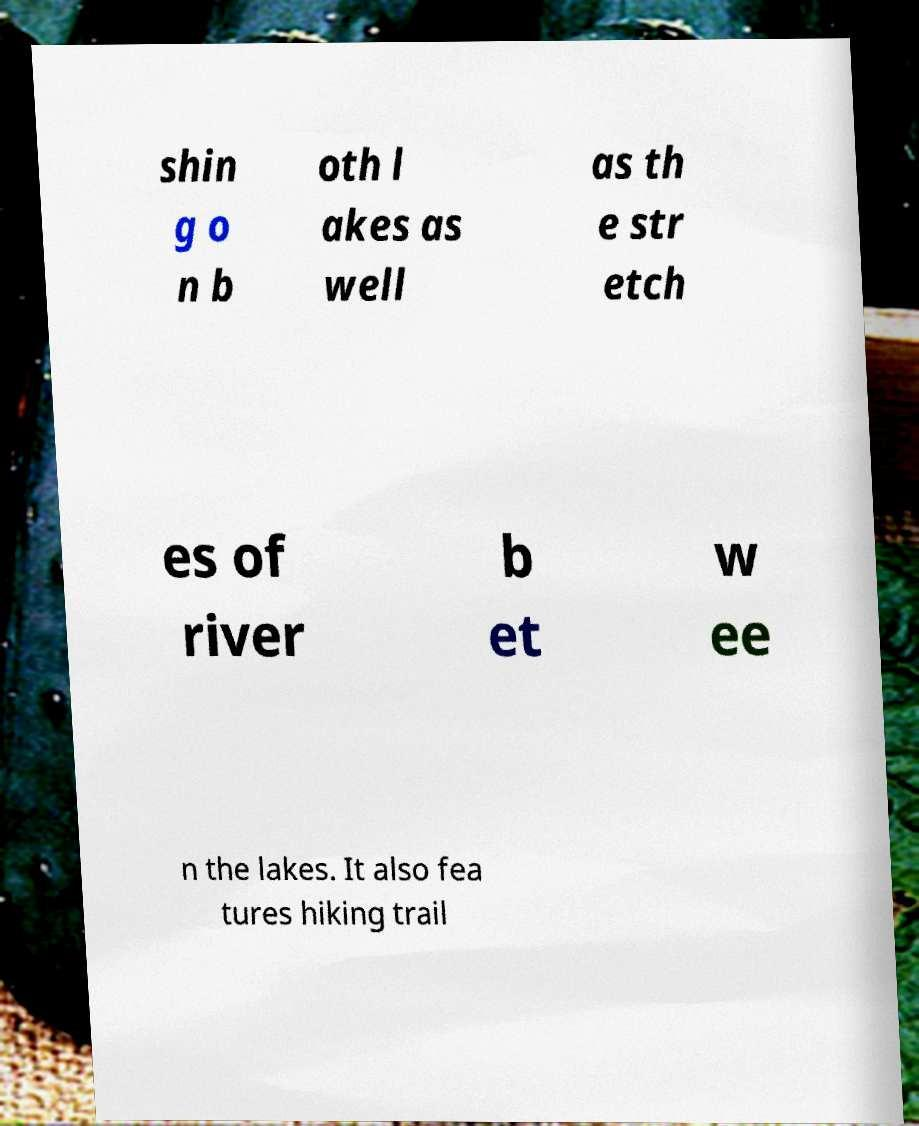For documentation purposes, I need the text within this image transcribed. Could you provide that? shin g o n b oth l akes as well as th e str etch es of river b et w ee n the lakes. It also fea tures hiking trail 